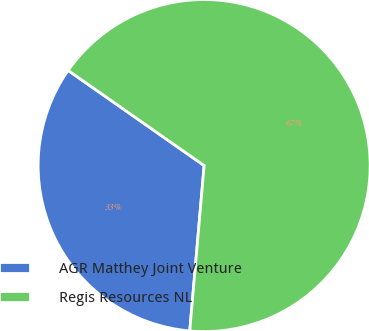Convert chart. <chart><loc_0><loc_0><loc_500><loc_500><pie_chart><fcel>AGR Matthey Joint Venture<fcel>Regis Resources NL<nl><fcel>33.33%<fcel>66.67%<nl></chart> 